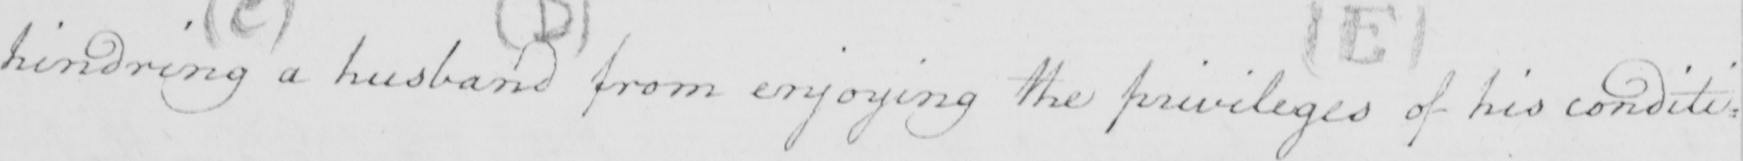Transcribe the text shown in this historical manuscript line. hindring a husband from enjoying the privileges of his condit : 